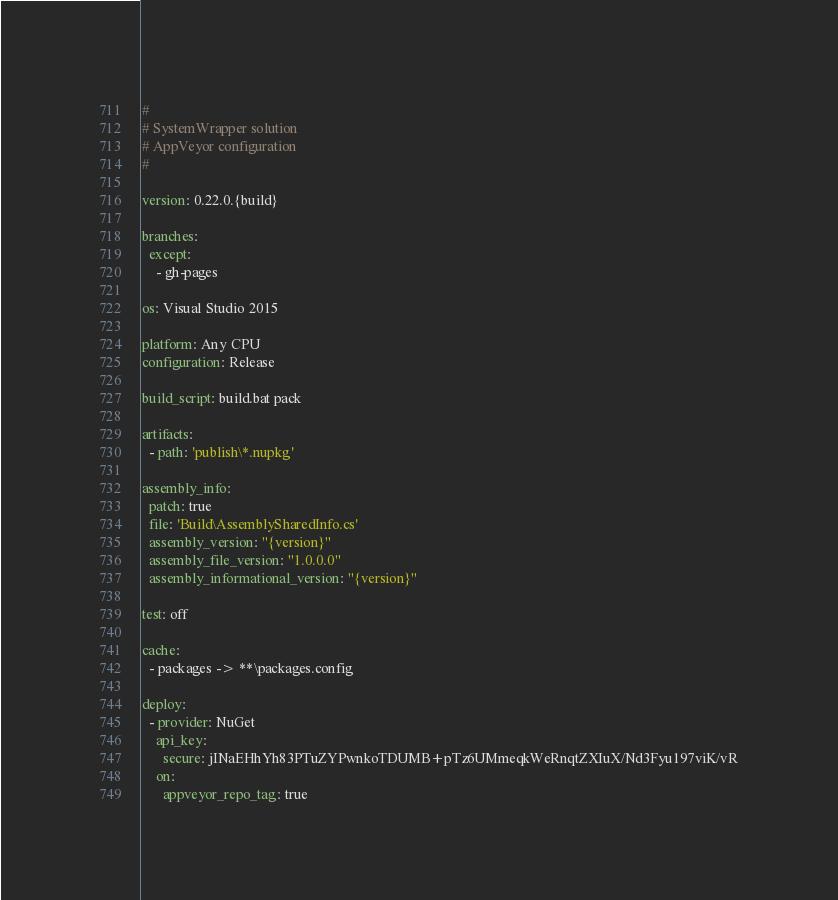Convert code to text. <code><loc_0><loc_0><loc_500><loc_500><_YAML_>#
# SystemWrapper solution
# AppVeyor configuration
#

version: 0.22.0.{build}

branches:
  except:
    - gh-pages

os: Visual Studio 2015

platform: Any CPU
configuration: Release

build_script: build.bat pack

artifacts:
  - path: 'publish\*.nupkg'

assembly_info:
  patch: true
  file: 'Build\AssemblySharedInfo.cs'
  assembly_version: "{version}"
  assembly_file_version: "1.0.0.0"
  assembly_informational_version: "{version}"

test: off

cache:
  - packages -> **\packages.config

deploy:
  - provider: NuGet
    api_key: 
      secure: jINaEHhYh83PTuZYPwnkoTDUMB+pTz6UMmeqkWeRnqtZXIuX/Nd3Fyu197viK/vR
    on:
      appveyor_repo_tag: true
</code> 